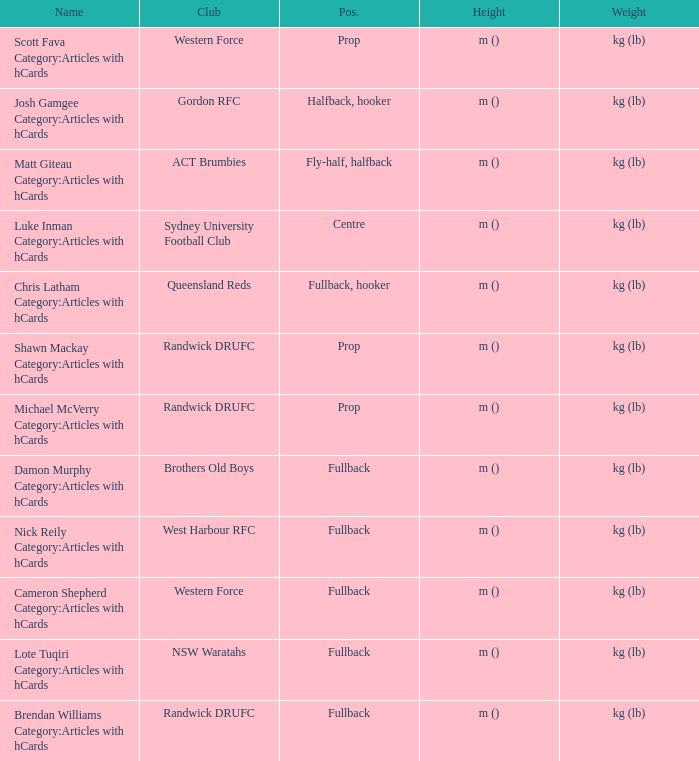What is the name when the position is centre? Luke Inman Category:Articles with hCards. 